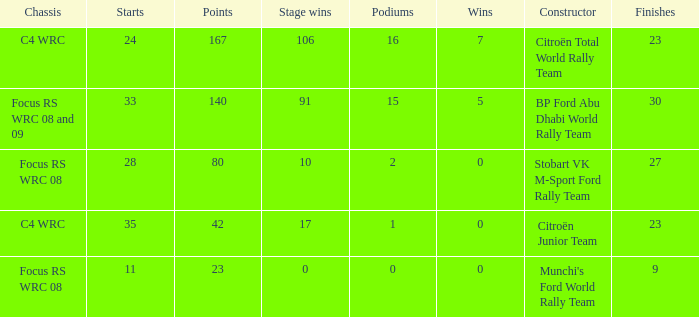What is the total number of points when the constructor is citroën total world rally team and the wins is less than 7? 0.0. 